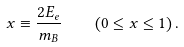<formula> <loc_0><loc_0><loc_500><loc_500>x \equiv \frac { 2 E _ { e } } { m _ { B } } \quad \left ( 0 \leq x \leq 1 \right ) .</formula> 